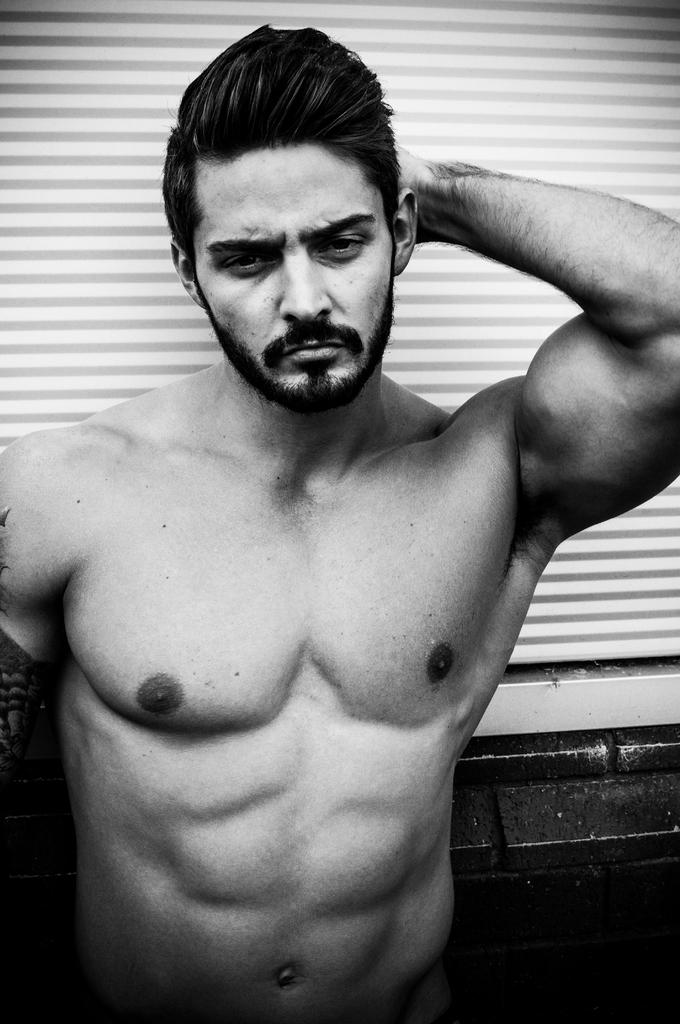What is the color scheme of the image? The image is black and white. Who or what is the main subject in the image? There is a man standing in the middle of the image. What is the man standing on? The man is standing on the floor. What can be seen in the background of the image? There is a blind in the background of the image. What flavor of ice cream is the man holding in the image? There is no ice cream present in the image, and the man is not holding anything. 